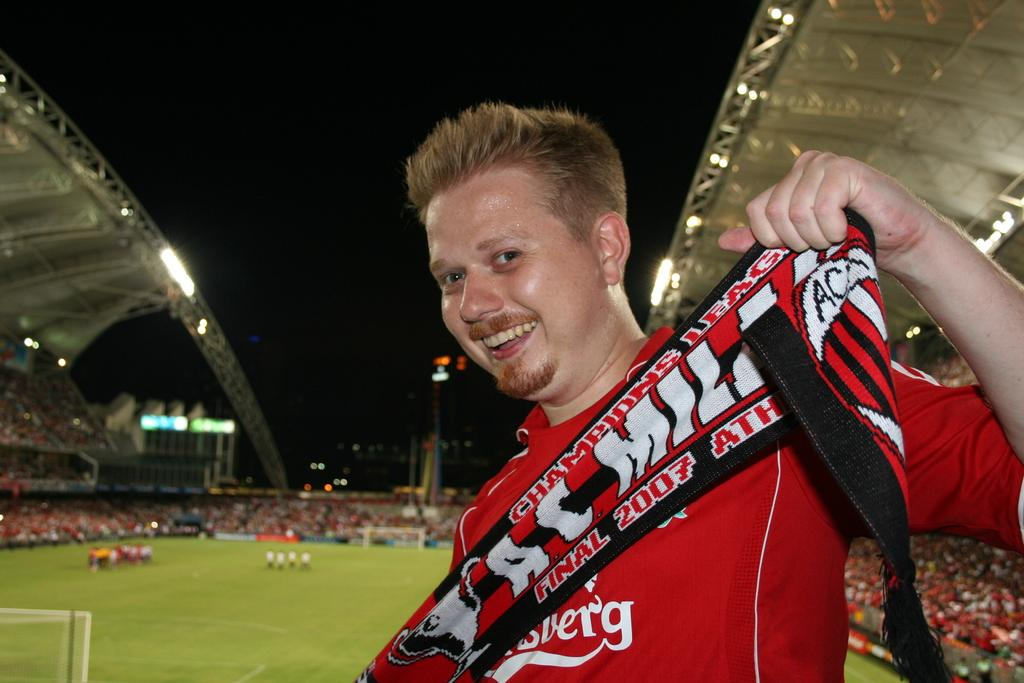<image>
Give a short and clear explanation of the subsequent image. Man at a football game showing off his shirt that says "Final 2007". 